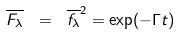<formula> <loc_0><loc_0><loc_500><loc_500>\overline { F _ { \lambda } } \ = \ \overline { f _ { \lambda } } ^ { 2 } = \exp ( - \Gamma t ) \</formula> 